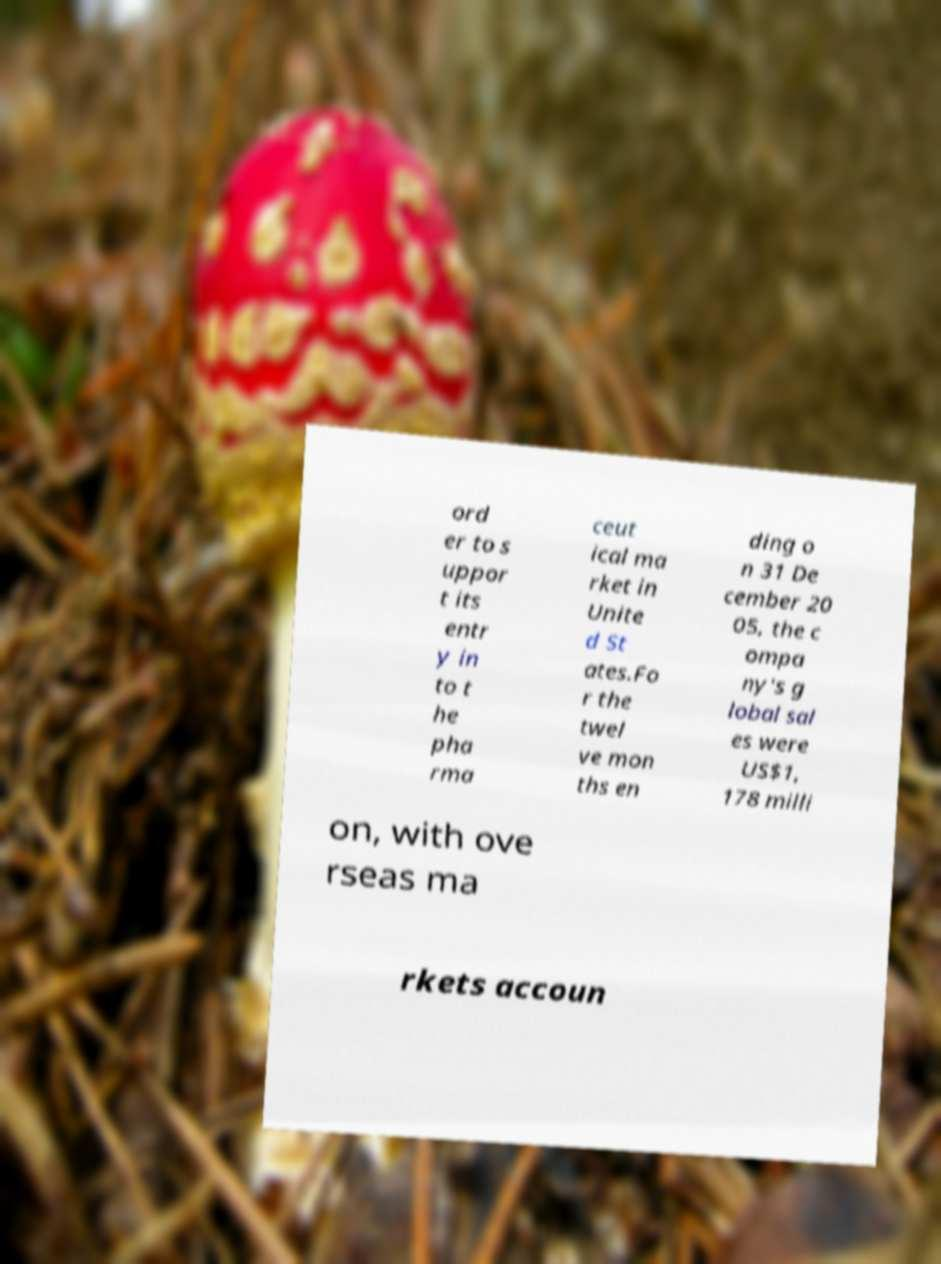Could you assist in decoding the text presented in this image and type it out clearly? ord er to s uppor t its entr y in to t he pha rma ceut ical ma rket in Unite d St ates.Fo r the twel ve mon ths en ding o n 31 De cember 20 05, the c ompa ny's g lobal sal es were US$1, 178 milli on, with ove rseas ma rkets accoun 